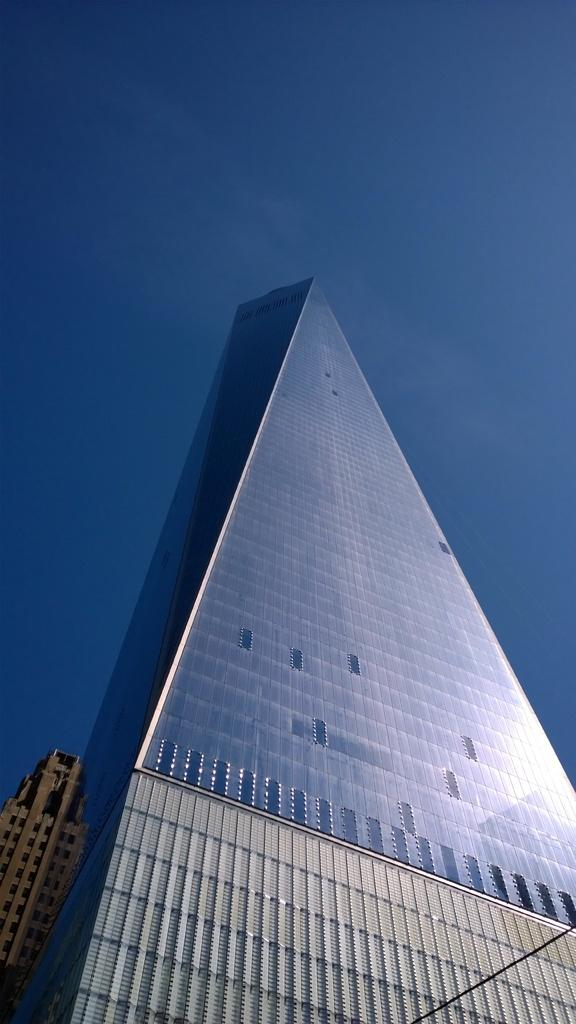How many buildings can be seen in the image? There are two buildings in the image. What feature do the buildings have in common? The buildings have windows. What can be seen in the background of the image? The sky is visible in the background of the image. What type of plant is growing on the side of the building in the image? There is no plant growing on the side of the building in the image. What is the address of the home in the image? There is no home present in the image, only two buildings. 